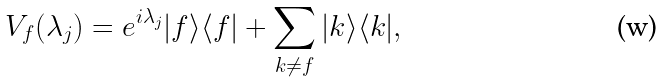<formula> <loc_0><loc_0><loc_500><loc_500>V _ { f } ( \lambda _ { j } ) = e ^ { i \lambda _ { j } } | f \rangle \langle f | + \sum _ { k \neq f } | k \rangle \langle k | , \,</formula> 